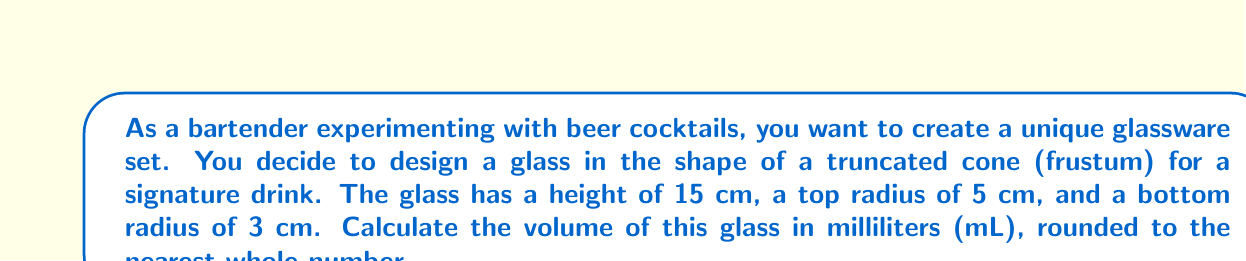Teach me how to tackle this problem. To solve this problem, we'll use the formula for the volume of a truncated cone (frustum):

$$V = \frac{1}{3}\pi h(R^2 + r^2 + Rr)$$

Where:
$V$ = volume
$h$ = height
$R$ = radius of the larger base (top)
$r$ = radius of the smaller base (bottom)

Given:
$h = 15$ cm
$R = 5$ cm
$r = 3$ cm

Let's substitute these values into the formula:

$$V = \frac{1}{3}\pi \cdot 15(5^2 + 3^2 + 5 \cdot 3)$$

Simplify:
$$V = 5\pi(25 + 9 + 15)$$
$$V = 5\pi(49)$$
$$V = 245\pi$$

Now, let's calculate this value:
$$V \approx 769.69 \text{ cm}^3$$

Since 1 cm³ = 1 mL, we can say the volume is approximately 769.69 mL.

Rounding to the nearest whole number:
$$V \approx 770 \text{ mL}$$
Answer: 770 mL 